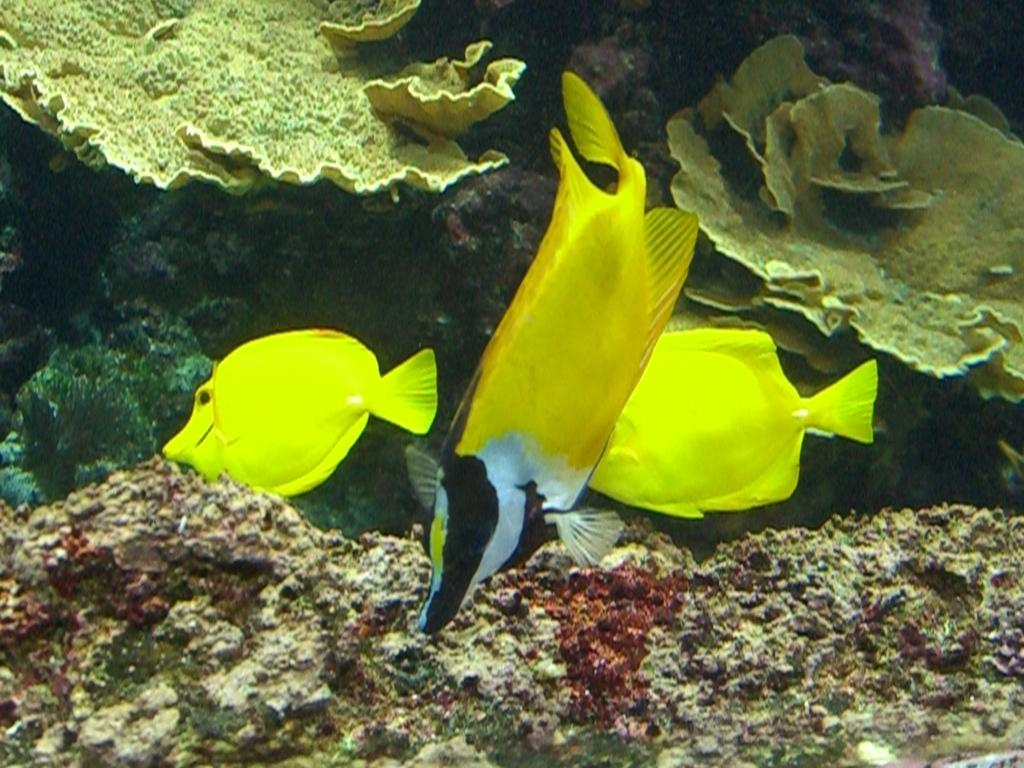How many fishes can be seen in the image? There are three fishes in the image. What are the fishes doing in the image? The fishes are moving in the water. What type of environment is depicted in the image? The image appears to be taken underwater. What can be seen in the background of the image? There are coral reefs visible in the image. How many eggs are being used to catch the fishes in the image? There are no eggs or fishing hooks present in the image; it depicts fishes moving in the water near coral reefs. 